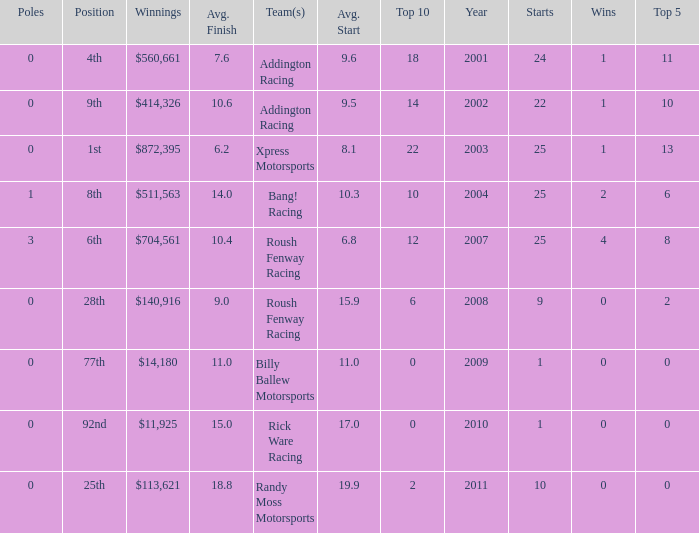How many wins in the 4th position? 1.0. 